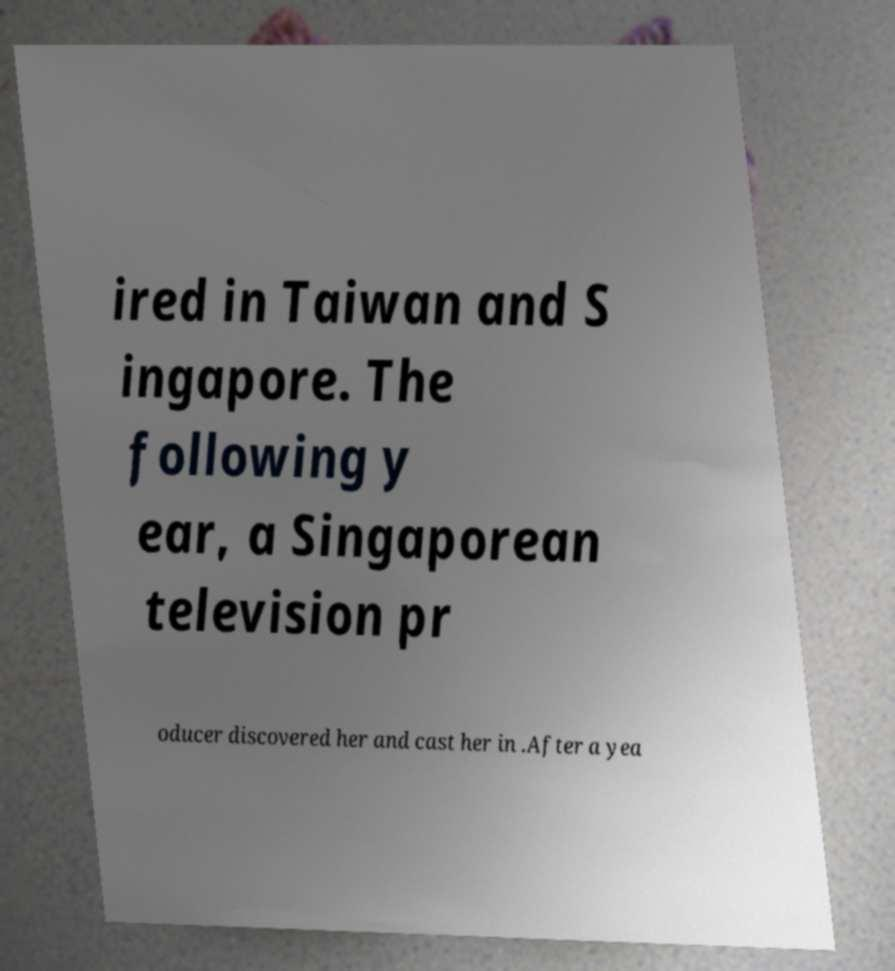Please identify and transcribe the text found in this image. ired in Taiwan and S ingapore. The following y ear, a Singaporean television pr oducer discovered her and cast her in .After a yea 